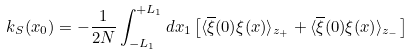<formula> <loc_0><loc_0><loc_500><loc_500>k _ { S } ( x _ { 0 } ) = - \frac { 1 } { 2 N } \int _ { - L _ { 1 } } ^ { + L _ { 1 } } d x _ { 1 } \left [ \langle \overline { \xi } ( 0 ) \xi ( x ) \rangle _ { z _ { + } } + \langle \overline { \xi } ( 0 ) \xi ( x ) \rangle _ { z _ { - } } \right ]</formula> 